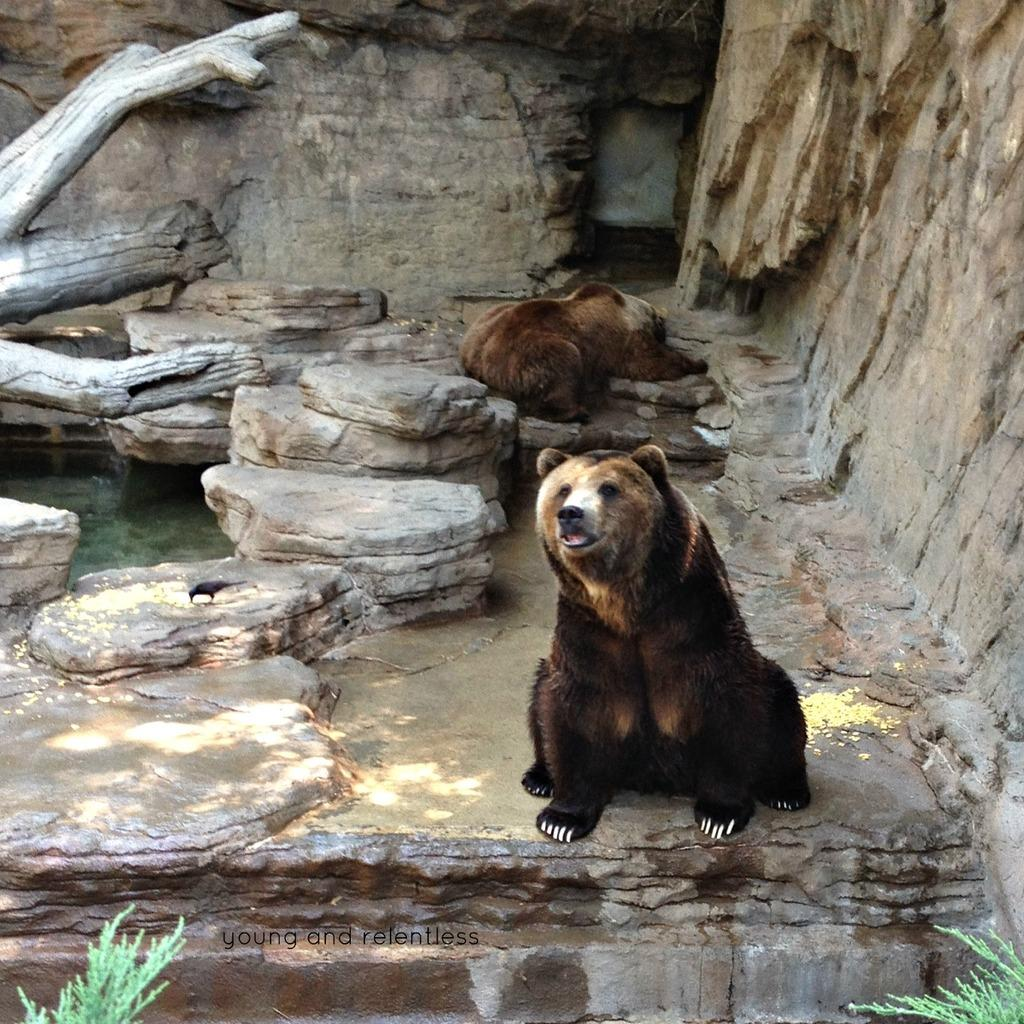What is on the rock in the image? There are animals and a bird on the rock in the image. What can be seen in the background of the image? There is water visible in the image. What object is present in the image that is typically used for carrying or storing items? There is a trunk in the image. What type of vegetation is in front of the rock in the image? There are plants in front of the rock in the image. What invention is being read by the animals on the rock in the image? There is no invention or book present in the image; it features animals and a bird on a rock with plants and water in the background. What type of arm is visible in the image? There are no arms visible in the image; it features animals, a bird, and a rock with plants and water in the background. 